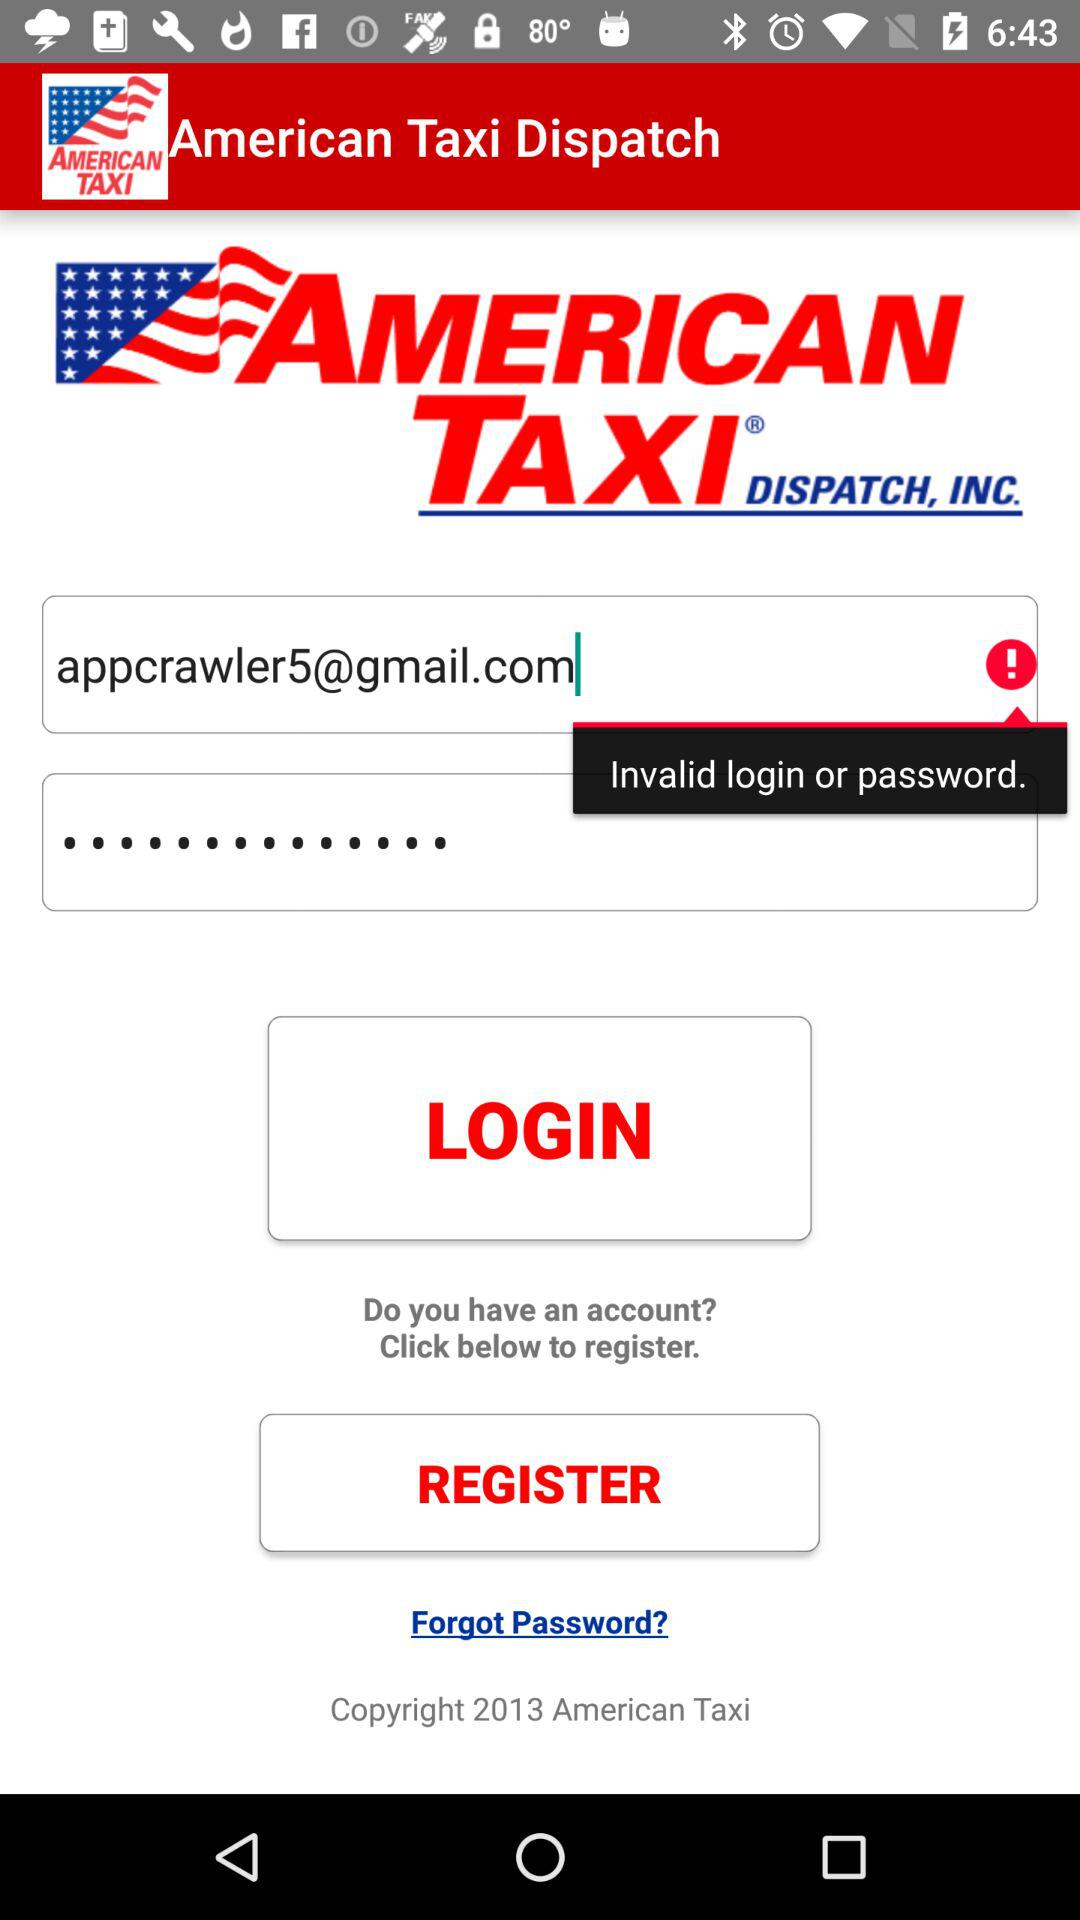What is the application name? The application name is "American Taxi Dispatch". 